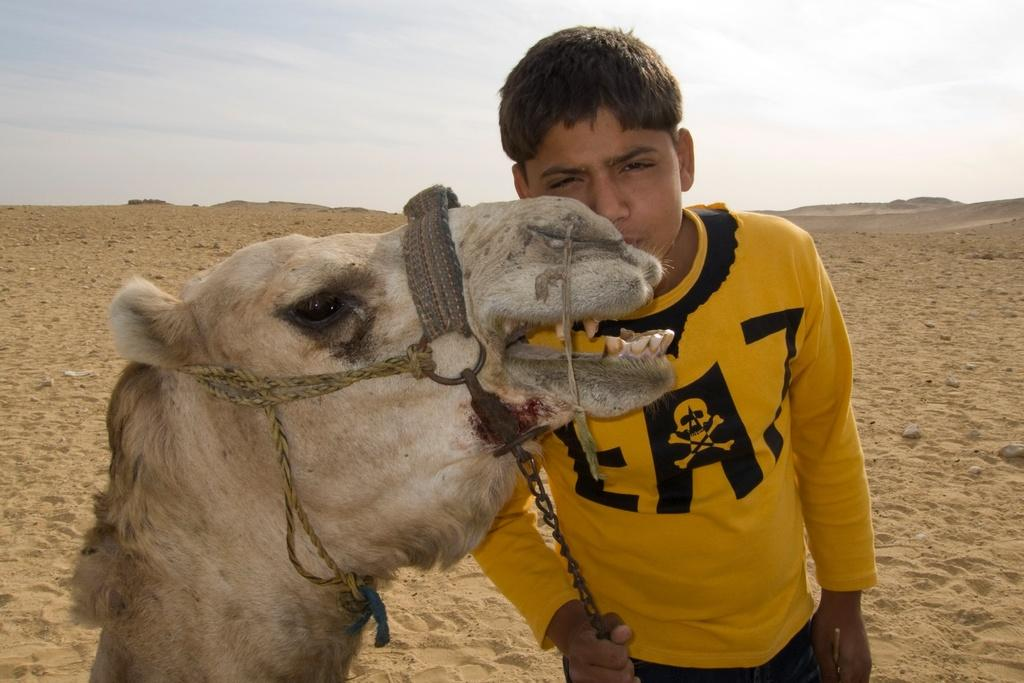What is the main subject of the image? There is a person in the image. What is the person wearing? The person is wearing a yellow t-shirt. What is the person holding? The person is holding a chain. What animal is in front of the person? There is a camel in front of the person. What type of terrain is visible in the image? There is sand visible in the image. What is visible in the background of the image? The sky is visible in the image. What is the name of the group performing in the winter scene in the image? There is no group performing in the image, nor is there any reference to a winter scene. 